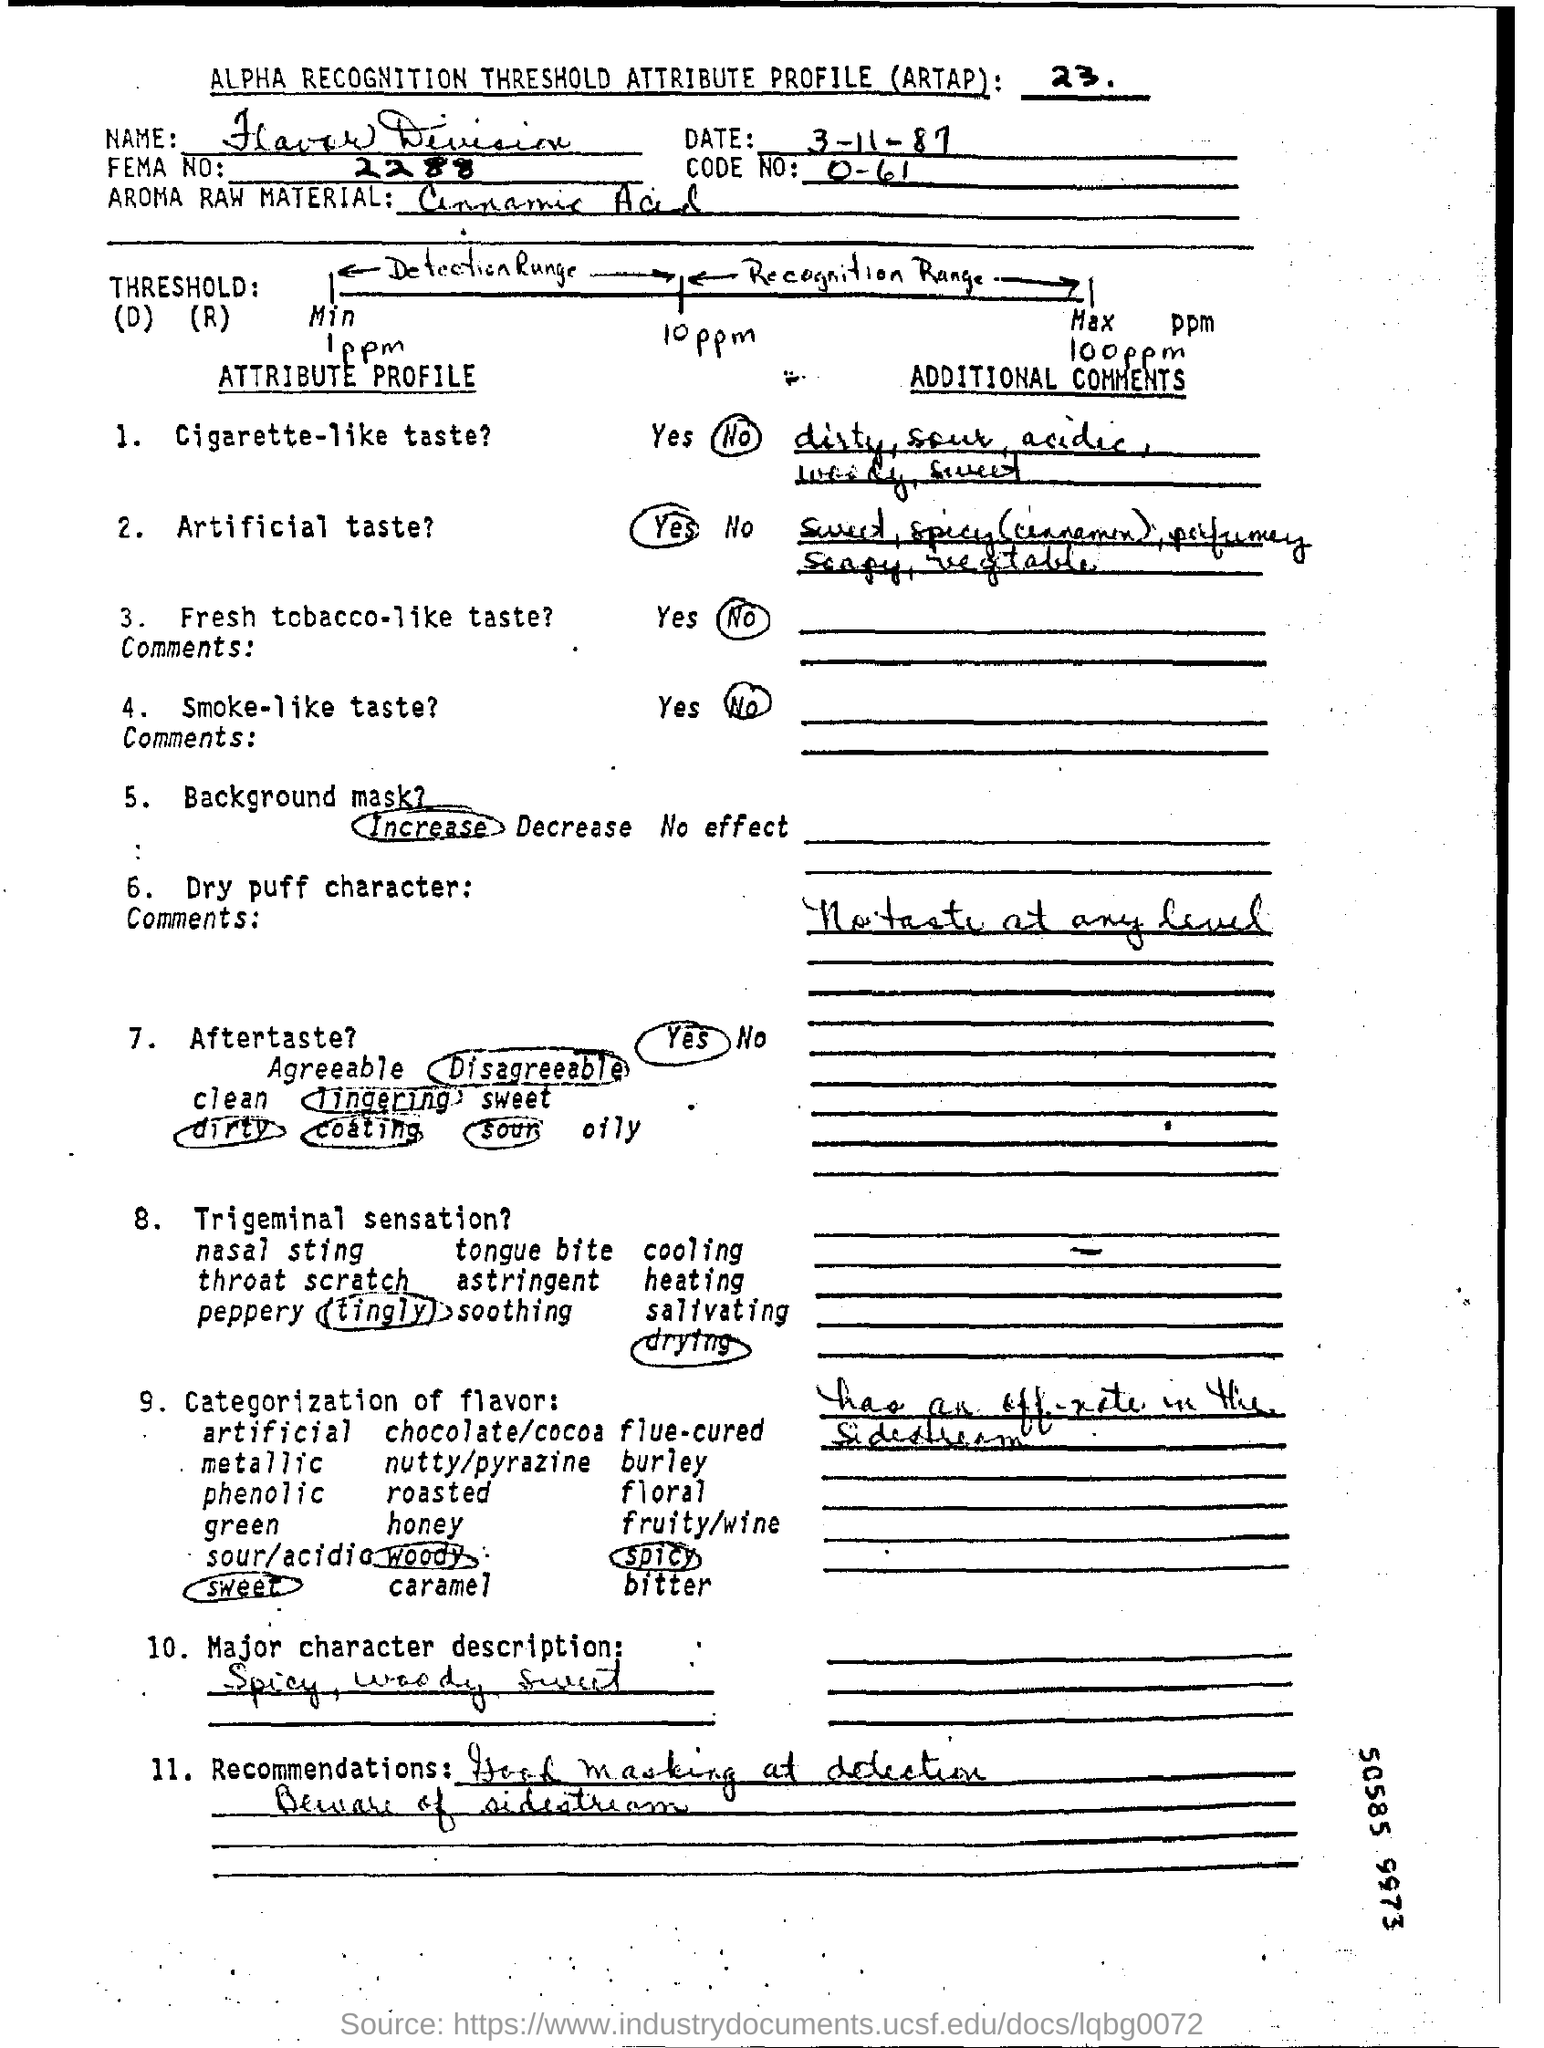Identify some key points in this picture. The date mentioned at the top of the document is 3 November 1987. The numeric value is 0 to 61, inclusive. FEMA number 2288," is a unique identifier assigned to individuals and organizations affected by disasters. 